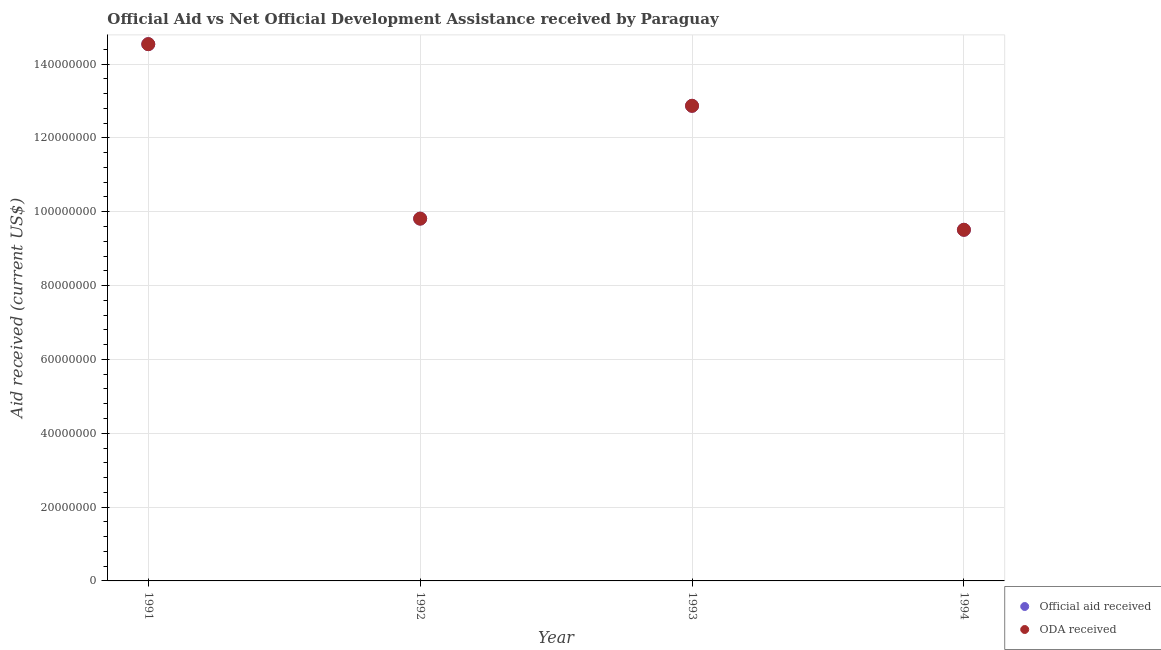Is the number of dotlines equal to the number of legend labels?
Give a very brief answer. Yes. What is the official aid received in 1991?
Provide a succinct answer. 1.45e+08. Across all years, what is the maximum oda received?
Your answer should be very brief. 1.45e+08. Across all years, what is the minimum oda received?
Your answer should be compact. 9.51e+07. In which year was the official aid received minimum?
Provide a short and direct response. 1994. What is the total oda received in the graph?
Provide a succinct answer. 4.67e+08. What is the difference between the official aid received in 1992 and that in 1993?
Offer a terse response. -3.06e+07. What is the difference between the oda received in 1993 and the official aid received in 1992?
Offer a very short reply. 3.06e+07. What is the average official aid received per year?
Your answer should be very brief. 1.17e+08. What is the ratio of the official aid received in 1993 to that in 1994?
Offer a very short reply. 1.35. Is the official aid received in 1991 less than that in 1992?
Offer a terse response. No. Is the difference between the official aid received in 1992 and 1993 greater than the difference between the oda received in 1992 and 1993?
Keep it short and to the point. No. What is the difference between the highest and the second highest official aid received?
Provide a short and direct response. 1.67e+07. What is the difference between the highest and the lowest official aid received?
Your response must be concise. 5.03e+07. Is the sum of the oda received in 1993 and 1994 greater than the maximum official aid received across all years?
Your response must be concise. Yes. Is the oda received strictly greater than the official aid received over the years?
Your answer should be compact. No. How many dotlines are there?
Your answer should be compact. 2. What is the difference between two consecutive major ticks on the Y-axis?
Keep it short and to the point. 2.00e+07. Are the values on the major ticks of Y-axis written in scientific E-notation?
Offer a terse response. No. Does the graph contain grids?
Your answer should be very brief. Yes. How are the legend labels stacked?
Your answer should be very brief. Vertical. What is the title of the graph?
Your answer should be compact. Official Aid vs Net Official Development Assistance received by Paraguay . What is the label or title of the X-axis?
Your answer should be compact. Year. What is the label or title of the Y-axis?
Give a very brief answer. Aid received (current US$). What is the Aid received (current US$) in Official aid received in 1991?
Your response must be concise. 1.45e+08. What is the Aid received (current US$) of ODA received in 1991?
Provide a short and direct response. 1.45e+08. What is the Aid received (current US$) in Official aid received in 1992?
Keep it short and to the point. 9.81e+07. What is the Aid received (current US$) in ODA received in 1992?
Make the answer very short. 9.81e+07. What is the Aid received (current US$) of Official aid received in 1993?
Your answer should be compact. 1.29e+08. What is the Aid received (current US$) of ODA received in 1993?
Give a very brief answer. 1.29e+08. What is the Aid received (current US$) in Official aid received in 1994?
Your answer should be compact. 9.51e+07. What is the Aid received (current US$) of ODA received in 1994?
Offer a terse response. 9.51e+07. Across all years, what is the maximum Aid received (current US$) in Official aid received?
Your answer should be compact. 1.45e+08. Across all years, what is the maximum Aid received (current US$) in ODA received?
Ensure brevity in your answer.  1.45e+08. Across all years, what is the minimum Aid received (current US$) of Official aid received?
Provide a short and direct response. 9.51e+07. Across all years, what is the minimum Aid received (current US$) in ODA received?
Make the answer very short. 9.51e+07. What is the total Aid received (current US$) of Official aid received in the graph?
Give a very brief answer. 4.67e+08. What is the total Aid received (current US$) in ODA received in the graph?
Keep it short and to the point. 4.67e+08. What is the difference between the Aid received (current US$) of Official aid received in 1991 and that in 1992?
Give a very brief answer. 4.73e+07. What is the difference between the Aid received (current US$) in ODA received in 1991 and that in 1992?
Offer a very short reply. 4.73e+07. What is the difference between the Aid received (current US$) in Official aid received in 1991 and that in 1993?
Your answer should be compact. 1.67e+07. What is the difference between the Aid received (current US$) in ODA received in 1991 and that in 1993?
Provide a short and direct response. 1.67e+07. What is the difference between the Aid received (current US$) of Official aid received in 1991 and that in 1994?
Give a very brief answer. 5.03e+07. What is the difference between the Aid received (current US$) in ODA received in 1991 and that in 1994?
Offer a very short reply. 5.03e+07. What is the difference between the Aid received (current US$) of Official aid received in 1992 and that in 1993?
Offer a terse response. -3.06e+07. What is the difference between the Aid received (current US$) of ODA received in 1992 and that in 1993?
Your response must be concise. -3.06e+07. What is the difference between the Aid received (current US$) of Official aid received in 1992 and that in 1994?
Make the answer very short. 3.02e+06. What is the difference between the Aid received (current US$) in ODA received in 1992 and that in 1994?
Your answer should be very brief. 3.02e+06. What is the difference between the Aid received (current US$) in Official aid received in 1993 and that in 1994?
Your answer should be compact. 3.36e+07. What is the difference between the Aid received (current US$) in ODA received in 1993 and that in 1994?
Keep it short and to the point. 3.36e+07. What is the difference between the Aid received (current US$) of Official aid received in 1991 and the Aid received (current US$) of ODA received in 1992?
Ensure brevity in your answer.  4.73e+07. What is the difference between the Aid received (current US$) in Official aid received in 1991 and the Aid received (current US$) in ODA received in 1993?
Provide a short and direct response. 1.67e+07. What is the difference between the Aid received (current US$) of Official aid received in 1991 and the Aid received (current US$) of ODA received in 1994?
Ensure brevity in your answer.  5.03e+07. What is the difference between the Aid received (current US$) of Official aid received in 1992 and the Aid received (current US$) of ODA received in 1993?
Offer a terse response. -3.06e+07. What is the difference between the Aid received (current US$) in Official aid received in 1992 and the Aid received (current US$) in ODA received in 1994?
Offer a very short reply. 3.02e+06. What is the difference between the Aid received (current US$) of Official aid received in 1993 and the Aid received (current US$) of ODA received in 1994?
Your answer should be compact. 3.36e+07. What is the average Aid received (current US$) in Official aid received per year?
Provide a short and direct response. 1.17e+08. What is the average Aid received (current US$) of ODA received per year?
Make the answer very short. 1.17e+08. In the year 1991, what is the difference between the Aid received (current US$) in Official aid received and Aid received (current US$) in ODA received?
Your answer should be very brief. 0. In the year 1992, what is the difference between the Aid received (current US$) of Official aid received and Aid received (current US$) of ODA received?
Your answer should be compact. 0. In the year 1994, what is the difference between the Aid received (current US$) in Official aid received and Aid received (current US$) in ODA received?
Provide a succinct answer. 0. What is the ratio of the Aid received (current US$) in Official aid received in 1991 to that in 1992?
Provide a short and direct response. 1.48. What is the ratio of the Aid received (current US$) in ODA received in 1991 to that in 1992?
Your answer should be very brief. 1.48. What is the ratio of the Aid received (current US$) of Official aid received in 1991 to that in 1993?
Give a very brief answer. 1.13. What is the ratio of the Aid received (current US$) of ODA received in 1991 to that in 1993?
Provide a short and direct response. 1.13. What is the ratio of the Aid received (current US$) in Official aid received in 1991 to that in 1994?
Ensure brevity in your answer.  1.53. What is the ratio of the Aid received (current US$) of ODA received in 1991 to that in 1994?
Provide a succinct answer. 1.53. What is the ratio of the Aid received (current US$) in Official aid received in 1992 to that in 1993?
Provide a short and direct response. 0.76. What is the ratio of the Aid received (current US$) in ODA received in 1992 to that in 1993?
Keep it short and to the point. 0.76. What is the ratio of the Aid received (current US$) in Official aid received in 1992 to that in 1994?
Give a very brief answer. 1.03. What is the ratio of the Aid received (current US$) of ODA received in 1992 to that in 1994?
Ensure brevity in your answer.  1.03. What is the ratio of the Aid received (current US$) in Official aid received in 1993 to that in 1994?
Offer a very short reply. 1.35. What is the ratio of the Aid received (current US$) in ODA received in 1993 to that in 1994?
Offer a terse response. 1.35. What is the difference between the highest and the second highest Aid received (current US$) in Official aid received?
Offer a terse response. 1.67e+07. What is the difference between the highest and the second highest Aid received (current US$) of ODA received?
Your response must be concise. 1.67e+07. What is the difference between the highest and the lowest Aid received (current US$) of Official aid received?
Offer a terse response. 5.03e+07. What is the difference between the highest and the lowest Aid received (current US$) of ODA received?
Provide a succinct answer. 5.03e+07. 